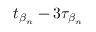<formula> <loc_0><loc_0><loc_500><loc_500>t _ { \beta _ { n } } - 3 \tau _ { \beta _ { n } }</formula> 